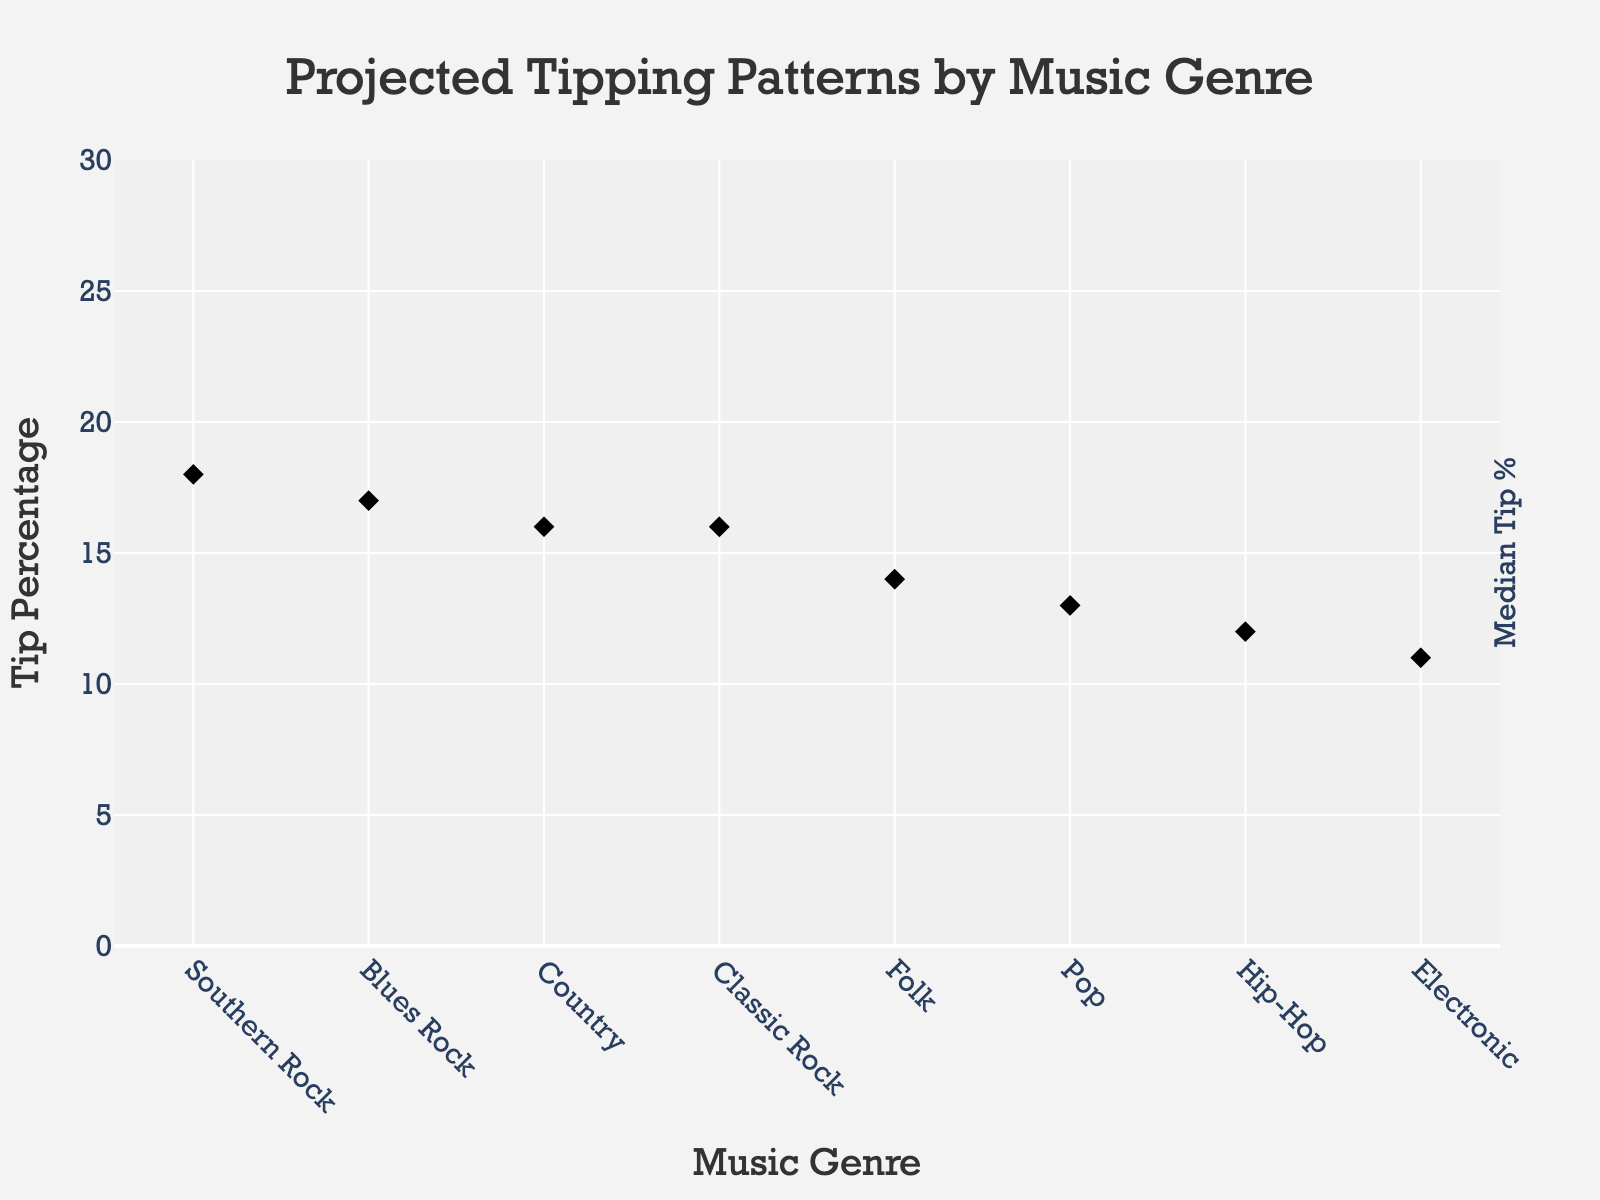Which music genre shows the highest maximum tip percentage? Look at the fan plot and identify which genre has the highest boundary on the vertical axis. Southern Rock's maximum tip percentage reaches 28%.
Answer: Southern Rock What is the median tip percentage for Country music? Find the data point in the middle line (diamond symbol) for the Country genre. It is shown at 16%.
Answer: 16% How does the median tip percentage of Classic Rock compare with that of Folk? Compare the middle lines (diamond symbols) of both genres. Classic Rock has a median tip of 16%, while Folk has a median tip of 14%. Therefore, Classic Rock's median is higher by 2%.
Answer: Classic Rock is higher by 2% What's the range of tip percentages for Pop music? Check for the minimum and maximum boundaries of Pop music. The range is calculated by subtracting the minimum tip percentage (7%) from the maximum tip percentage (20%).
Answer: 13% Which music genre has the lowest lower quartile tip percentage? Look at the lower quartile boundaries of all genres and identify the smallest one. Electronic has the lowest lower quartile tip percentage at 8%.
Answer: Electronic What is the interquartile range (IQR) for Hip-Hop music? IQR is calculated by subtracting the lower quartile (9%) from the upper quartile (15%) of Hip-Hop music.
Answer: 6% Which musical genre has the smallest difference between its upper and lower quartile tip percentages? Compare the width of the quartile range for each genre. For Country, the difference is 19% - 14% = 5%. The minimum difference among all genres is for Country music.
Answer: Country What's the difference between the median and the maximum tip percentage for Blues Rock? Subtract the median tip percentage (17%) from the maximum tip percentage (25%) for Blues Rock.
Answer: 8% Which genre shows the widest spread in tip percentages? Identify which genre has the highest difference between its maximum and minimum tip percentages. Southern Rock spans from 12% to 28%, making a spread of 16%.
Answer: Southern Rock What genre offers the highest median tip percentage? Evaluate the middle data points (diamond symbols) to find the highest median tip percentage. Southern Rock has the highest median tip percentage at 18%.
Answer: Southern Rock 